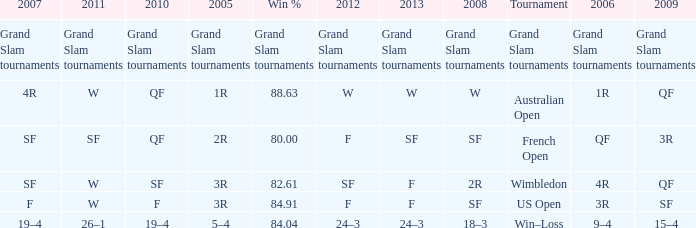Would you mind parsing the complete table? {'header': ['2007', '2011', '2010', '2005', 'Win %', '2012', '2013', '2008', 'Tournament', '2006', '2009'], 'rows': [['Grand Slam tournaments', 'Grand Slam tournaments', 'Grand Slam tournaments', 'Grand Slam tournaments', 'Grand Slam tournaments', 'Grand Slam tournaments', 'Grand Slam tournaments', 'Grand Slam tournaments', 'Grand Slam tournaments', 'Grand Slam tournaments', 'Grand Slam tournaments'], ['4R', 'W', 'QF', '1R', '88.63', 'W', 'W', 'W', 'Australian Open', '1R', 'QF'], ['SF', 'SF', 'QF', '2R', '80.00', 'F', 'SF', 'SF', 'French Open', 'QF', '3R'], ['SF', 'W', 'SF', '3R', '82.61', 'SF', 'F', '2R', 'Wimbledon', '4R', 'QF'], ['F', 'W', 'F', '3R', '84.91', 'F', 'F', 'SF', 'US Open', '3R', 'SF'], ['19–4', '26–1', '19–4', '5–4', '84.04', '24–3', '24–3', '18–3', 'Win–Loss', '9–4', '15–4']]} When in 2008 that has a 2007 of f? SF. 